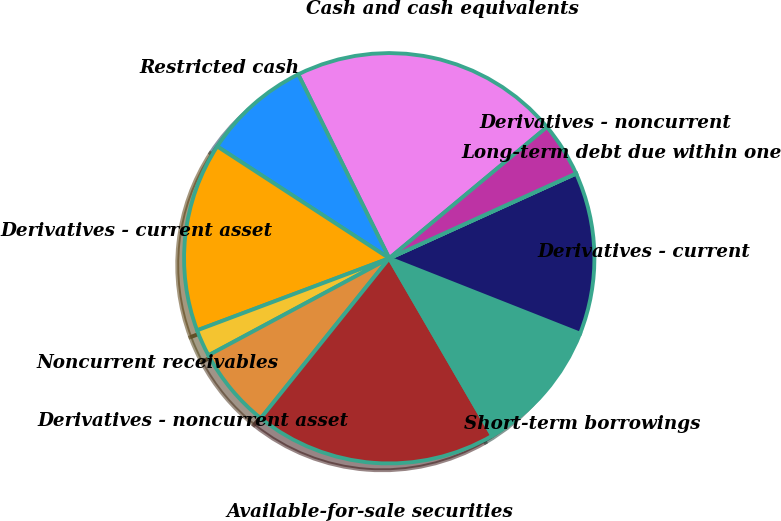Convert chart. <chart><loc_0><loc_0><loc_500><loc_500><pie_chart><fcel>Cash and cash equivalents<fcel>Restricted cash<fcel>Derivatives - current asset<fcel>Noncurrent receivables<fcel>Derivatives - noncurrent asset<fcel>Available-for-sale securities<fcel>Short-term borrowings<fcel>Derivatives - current<fcel>Long-term debt due within one<fcel>Derivatives - noncurrent<nl><fcel>21.27%<fcel>8.51%<fcel>14.89%<fcel>2.13%<fcel>6.39%<fcel>19.14%<fcel>10.64%<fcel>12.76%<fcel>0.01%<fcel>4.26%<nl></chart> 